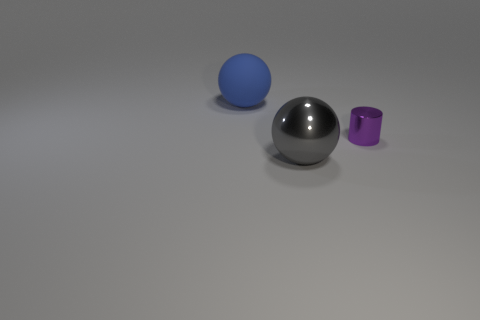Add 1 large blue metallic cubes. How many objects exist? 4 Subtract all cylinders. How many objects are left? 2 Add 2 big blue spheres. How many big blue spheres are left? 3 Add 1 matte balls. How many matte balls exist? 2 Subtract 0 red balls. How many objects are left? 3 Subtract all brown balls. Subtract all cyan cylinders. How many balls are left? 2 Subtract all metal balls. Subtract all gray things. How many objects are left? 1 